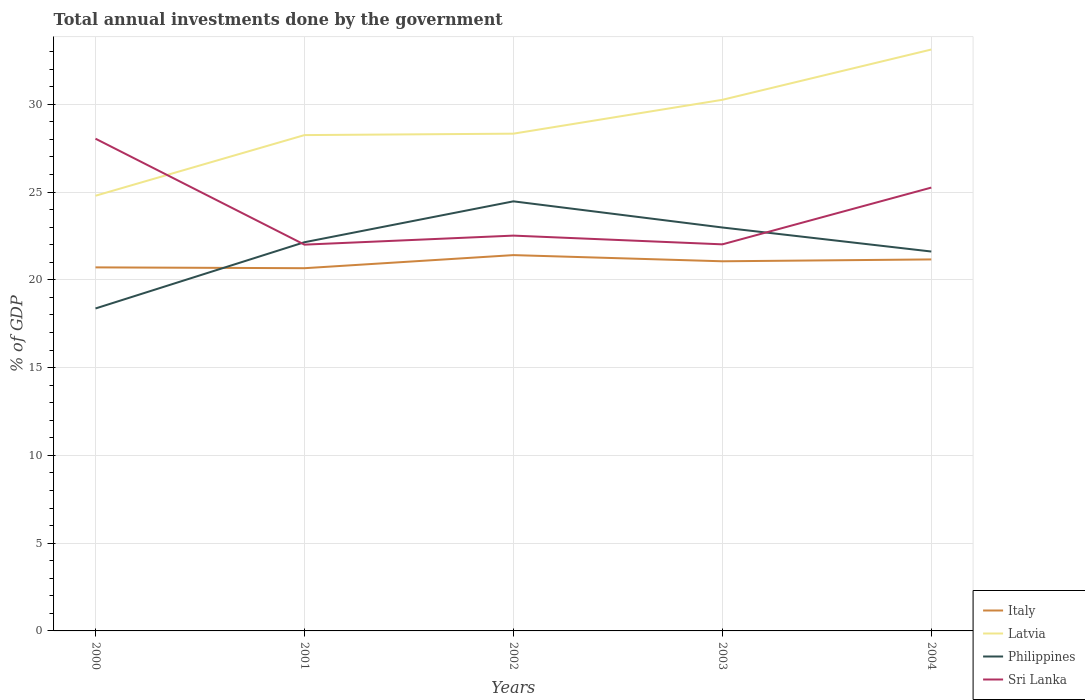How many different coloured lines are there?
Offer a terse response. 4. Across all years, what is the maximum total annual investments done by the government in Sri Lanka?
Ensure brevity in your answer.  22. What is the total total annual investments done by the government in Latvia in the graph?
Your response must be concise. -2.86. What is the difference between the highest and the second highest total annual investments done by the government in Italy?
Provide a succinct answer. 0.75. How many lines are there?
Make the answer very short. 4. How many years are there in the graph?
Make the answer very short. 5. Are the values on the major ticks of Y-axis written in scientific E-notation?
Offer a very short reply. No. Where does the legend appear in the graph?
Offer a very short reply. Bottom right. How many legend labels are there?
Your answer should be compact. 4. How are the legend labels stacked?
Keep it short and to the point. Vertical. What is the title of the graph?
Offer a very short reply. Total annual investments done by the government. What is the label or title of the X-axis?
Offer a very short reply. Years. What is the label or title of the Y-axis?
Make the answer very short. % of GDP. What is the % of GDP of Italy in 2000?
Your answer should be compact. 20.71. What is the % of GDP of Latvia in 2000?
Keep it short and to the point. 24.79. What is the % of GDP of Philippines in 2000?
Make the answer very short. 18.37. What is the % of GDP in Sri Lanka in 2000?
Your answer should be very brief. 28.04. What is the % of GDP in Italy in 2001?
Keep it short and to the point. 20.66. What is the % of GDP of Latvia in 2001?
Offer a terse response. 28.24. What is the % of GDP in Philippines in 2001?
Provide a succinct answer. 22.14. What is the % of GDP of Sri Lanka in 2001?
Provide a short and direct response. 22. What is the % of GDP in Italy in 2002?
Give a very brief answer. 21.41. What is the % of GDP of Latvia in 2002?
Provide a succinct answer. 28.33. What is the % of GDP of Philippines in 2002?
Your response must be concise. 24.47. What is the % of GDP in Sri Lanka in 2002?
Your response must be concise. 22.52. What is the % of GDP in Italy in 2003?
Your answer should be very brief. 21.06. What is the % of GDP of Latvia in 2003?
Provide a short and direct response. 30.25. What is the % of GDP in Philippines in 2003?
Give a very brief answer. 22.98. What is the % of GDP in Sri Lanka in 2003?
Ensure brevity in your answer.  22.02. What is the % of GDP of Italy in 2004?
Your answer should be very brief. 21.16. What is the % of GDP of Latvia in 2004?
Make the answer very short. 33.12. What is the % of GDP in Philippines in 2004?
Your answer should be compact. 21.61. What is the % of GDP of Sri Lanka in 2004?
Provide a short and direct response. 25.25. Across all years, what is the maximum % of GDP of Italy?
Give a very brief answer. 21.41. Across all years, what is the maximum % of GDP in Latvia?
Your response must be concise. 33.12. Across all years, what is the maximum % of GDP of Philippines?
Keep it short and to the point. 24.47. Across all years, what is the maximum % of GDP in Sri Lanka?
Offer a terse response. 28.04. Across all years, what is the minimum % of GDP of Italy?
Keep it short and to the point. 20.66. Across all years, what is the minimum % of GDP of Latvia?
Provide a short and direct response. 24.79. Across all years, what is the minimum % of GDP in Philippines?
Offer a terse response. 18.37. Across all years, what is the minimum % of GDP in Sri Lanka?
Ensure brevity in your answer.  22. What is the total % of GDP of Italy in the graph?
Offer a terse response. 105. What is the total % of GDP of Latvia in the graph?
Offer a terse response. 144.73. What is the total % of GDP in Philippines in the graph?
Provide a succinct answer. 109.57. What is the total % of GDP of Sri Lanka in the graph?
Give a very brief answer. 119.84. What is the difference between the % of GDP in Italy in 2000 and that in 2001?
Keep it short and to the point. 0.05. What is the difference between the % of GDP of Latvia in 2000 and that in 2001?
Give a very brief answer. -3.45. What is the difference between the % of GDP in Philippines in 2000 and that in 2001?
Make the answer very short. -3.77. What is the difference between the % of GDP of Sri Lanka in 2000 and that in 2001?
Your answer should be very brief. 6.04. What is the difference between the % of GDP of Italy in 2000 and that in 2002?
Your answer should be compact. -0.7. What is the difference between the % of GDP of Latvia in 2000 and that in 2002?
Ensure brevity in your answer.  -3.54. What is the difference between the % of GDP in Philippines in 2000 and that in 2002?
Provide a succinct answer. -6.1. What is the difference between the % of GDP of Sri Lanka in 2000 and that in 2002?
Your answer should be compact. 5.52. What is the difference between the % of GDP in Italy in 2000 and that in 2003?
Ensure brevity in your answer.  -0.35. What is the difference between the % of GDP of Latvia in 2000 and that in 2003?
Offer a very short reply. -5.46. What is the difference between the % of GDP of Philippines in 2000 and that in 2003?
Ensure brevity in your answer.  -4.61. What is the difference between the % of GDP of Sri Lanka in 2000 and that in 2003?
Offer a terse response. 6.02. What is the difference between the % of GDP in Italy in 2000 and that in 2004?
Your answer should be very brief. -0.45. What is the difference between the % of GDP of Latvia in 2000 and that in 2004?
Your response must be concise. -8.33. What is the difference between the % of GDP in Philippines in 2000 and that in 2004?
Provide a succinct answer. -3.24. What is the difference between the % of GDP of Sri Lanka in 2000 and that in 2004?
Your answer should be very brief. 2.79. What is the difference between the % of GDP of Italy in 2001 and that in 2002?
Ensure brevity in your answer.  -0.75. What is the difference between the % of GDP in Latvia in 2001 and that in 2002?
Your answer should be compact. -0.08. What is the difference between the % of GDP in Philippines in 2001 and that in 2002?
Give a very brief answer. -2.33. What is the difference between the % of GDP of Sri Lanka in 2001 and that in 2002?
Ensure brevity in your answer.  -0.51. What is the difference between the % of GDP of Italy in 2001 and that in 2003?
Your answer should be very brief. -0.39. What is the difference between the % of GDP in Latvia in 2001 and that in 2003?
Your answer should be compact. -2.01. What is the difference between the % of GDP in Philippines in 2001 and that in 2003?
Provide a short and direct response. -0.84. What is the difference between the % of GDP in Sri Lanka in 2001 and that in 2003?
Your answer should be very brief. -0.02. What is the difference between the % of GDP in Italy in 2001 and that in 2004?
Provide a short and direct response. -0.5. What is the difference between the % of GDP of Latvia in 2001 and that in 2004?
Ensure brevity in your answer.  -4.87. What is the difference between the % of GDP in Philippines in 2001 and that in 2004?
Give a very brief answer. 0.53. What is the difference between the % of GDP of Sri Lanka in 2001 and that in 2004?
Give a very brief answer. -3.25. What is the difference between the % of GDP of Italy in 2002 and that in 2003?
Offer a terse response. 0.35. What is the difference between the % of GDP of Latvia in 2002 and that in 2003?
Provide a short and direct response. -1.93. What is the difference between the % of GDP of Philippines in 2002 and that in 2003?
Provide a short and direct response. 1.49. What is the difference between the % of GDP of Sri Lanka in 2002 and that in 2003?
Ensure brevity in your answer.  0.5. What is the difference between the % of GDP of Italy in 2002 and that in 2004?
Your answer should be compact. 0.25. What is the difference between the % of GDP in Latvia in 2002 and that in 2004?
Ensure brevity in your answer.  -4.79. What is the difference between the % of GDP in Philippines in 2002 and that in 2004?
Keep it short and to the point. 2.86. What is the difference between the % of GDP of Sri Lanka in 2002 and that in 2004?
Your answer should be compact. -2.74. What is the difference between the % of GDP of Italy in 2003 and that in 2004?
Offer a very short reply. -0.11. What is the difference between the % of GDP in Latvia in 2003 and that in 2004?
Offer a very short reply. -2.86. What is the difference between the % of GDP in Philippines in 2003 and that in 2004?
Offer a very short reply. 1.37. What is the difference between the % of GDP in Sri Lanka in 2003 and that in 2004?
Give a very brief answer. -3.23. What is the difference between the % of GDP in Italy in 2000 and the % of GDP in Latvia in 2001?
Provide a short and direct response. -7.53. What is the difference between the % of GDP of Italy in 2000 and the % of GDP of Philippines in 2001?
Keep it short and to the point. -1.43. What is the difference between the % of GDP of Italy in 2000 and the % of GDP of Sri Lanka in 2001?
Your response must be concise. -1.29. What is the difference between the % of GDP of Latvia in 2000 and the % of GDP of Philippines in 2001?
Ensure brevity in your answer.  2.65. What is the difference between the % of GDP in Latvia in 2000 and the % of GDP in Sri Lanka in 2001?
Provide a short and direct response. 2.79. What is the difference between the % of GDP of Philippines in 2000 and the % of GDP of Sri Lanka in 2001?
Your answer should be very brief. -3.64. What is the difference between the % of GDP of Italy in 2000 and the % of GDP of Latvia in 2002?
Ensure brevity in your answer.  -7.62. What is the difference between the % of GDP in Italy in 2000 and the % of GDP in Philippines in 2002?
Your answer should be compact. -3.76. What is the difference between the % of GDP of Italy in 2000 and the % of GDP of Sri Lanka in 2002?
Your answer should be very brief. -1.81. What is the difference between the % of GDP of Latvia in 2000 and the % of GDP of Philippines in 2002?
Offer a terse response. 0.32. What is the difference between the % of GDP in Latvia in 2000 and the % of GDP in Sri Lanka in 2002?
Ensure brevity in your answer.  2.27. What is the difference between the % of GDP of Philippines in 2000 and the % of GDP of Sri Lanka in 2002?
Make the answer very short. -4.15. What is the difference between the % of GDP in Italy in 2000 and the % of GDP in Latvia in 2003?
Provide a succinct answer. -9.54. What is the difference between the % of GDP in Italy in 2000 and the % of GDP in Philippines in 2003?
Provide a short and direct response. -2.27. What is the difference between the % of GDP in Italy in 2000 and the % of GDP in Sri Lanka in 2003?
Offer a terse response. -1.31. What is the difference between the % of GDP of Latvia in 2000 and the % of GDP of Philippines in 2003?
Your answer should be very brief. 1.81. What is the difference between the % of GDP in Latvia in 2000 and the % of GDP in Sri Lanka in 2003?
Offer a very short reply. 2.77. What is the difference between the % of GDP of Philippines in 2000 and the % of GDP of Sri Lanka in 2003?
Provide a short and direct response. -3.65. What is the difference between the % of GDP in Italy in 2000 and the % of GDP in Latvia in 2004?
Your answer should be very brief. -12.41. What is the difference between the % of GDP of Italy in 2000 and the % of GDP of Philippines in 2004?
Provide a succinct answer. -0.9. What is the difference between the % of GDP of Italy in 2000 and the % of GDP of Sri Lanka in 2004?
Provide a succinct answer. -4.54. What is the difference between the % of GDP in Latvia in 2000 and the % of GDP in Philippines in 2004?
Ensure brevity in your answer.  3.18. What is the difference between the % of GDP of Latvia in 2000 and the % of GDP of Sri Lanka in 2004?
Make the answer very short. -0.46. What is the difference between the % of GDP in Philippines in 2000 and the % of GDP in Sri Lanka in 2004?
Keep it short and to the point. -6.89. What is the difference between the % of GDP in Italy in 2001 and the % of GDP in Latvia in 2002?
Provide a short and direct response. -7.66. What is the difference between the % of GDP in Italy in 2001 and the % of GDP in Philippines in 2002?
Give a very brief answer. -3.81. What is the difference between the % of GDP of Italy in 2001 and the % of GDP of Sri Lanka in 2002?
Provide a succinct answer. -1.86. What is the difference between the % of GDP in Latvia in 2001 and the % of GDP in Philippines in 2002?
Offer a very short reply. 3.77. What is the difference between the % of GDP of Latvia in 2001 and the % of GDP of Sri Lanka in 2002?
Ensure brevity in your answer.  5.73. What is the difference between the % of GDP in Philippines in 2001 and the % of GDP in Sri Lanka in 2002?
Make the answer very short. -0.38. What is the difference between the % of GDP of Italy in 2001 and the % of GDP of Latvia in 2003?
Offer a very short reply. -9.59. What is the difference between the % of GDP in Italy in 2001 and the % of GDP in Philippines in 2003?
Provide a short and direct response. -2.32. What is the difference between the % of GDP in Italy in 2001 and the % of GDP in Sri Lanka in 2003?
Give a very brief answer. -1.36. What is the difference between the % of GDP of Latvia in 2001 and the % of GDP of Philippines in 2003?
Your answer should be compact. 5.26. What is the difference between the % of GDP of Latvia in 2001 and the % of GDP of Sri Lanka in 2003?
Give a very brief answer. 6.22. What is the difference between the % of GDP in Philippines in 2001 and the % of GDP in Sri Lanka in 2003?
Your answer should be very brief. 0.12. What is the difference between the % of GDP in Italy in 2001 and the % of GDP in Latvia in 2004?
Keep it short and to the point. -12.46. What is the difference between the % of GDP in Italy in 2001 and the % of GDP in Philippines in 2004?
Keep it short and to the point. -0.95. What is the difference between the % of GDP of Italy in 2001 and the % of GDP of Sri Lanka in 2004?
Offer a terse response. -4.59. What is the difference between the % of GDP of Latvia in 2001 and the % of GDP of Philippines in 2004?
Make the answer very short. 6.63. What is the difference between the % of GDP in Latvia in 2001 and the % of GDP in Sri Lanka in 2004?
Give a very brief answer. 2.99. What is the difference between the % of GDP in Philippines in 2001 and the % of GDP in Sri Lanka in 2004?
Provide a succinct answer. -3.11. What is the difference between the % of GDP of Italy in 2002 and the % of GDP of Latvia in 2003?
Your answer should be compact. -8.85. What is the difference between the % of GDP of Italy in 2002 and the % of GDP of Philippines in 2003?
Ensure brevity in your answer.  -1.57. What is the difference between the % of GDP in Italy in 2002 and the % of GDP in Sri Lanka in 2003?
Offer a terse response. -0.61. What is the difference between the % of GDP of Latvia in 2002 and the % of GDP of Philippines in 2003?
Your response must be concise. 5.34. What is the difference between the % of GDP in Latvia in 2002 and the % of GDP in Sri Lanka in 2003?
Offer a terse response. 6.3. What is the difference between the % of GDP in Philippines in 2002 and the % of GDP in Sri Lanka in 2003?
Ensure brevity in your answer.  2.45. What is the difference between the % of GDP of Italy in 2002 and the % of GDP of Latvia in 2004?
Offer a very short reply. -11.71. What is the difference between the % of GDP in Italy in 2002 and the % of GDP in Philippines in 2004?
Ensure brevity in your answer.  -0.2. What is the difference between the % of GDP of Italy in 2002 and the % of GDP of Sri Lanka in 2004?
Keep it short and to the point. -3.85. What is the difference between the % of GDP in Latvia in 2002 and the % of GDP in Philippines in 2004?
Offer a terse response. 6.71. What is the difference between the % of GDP of Latvia in 2002 and the % of GDP of Sri Lanka in 2004?
Your answer should be compact. 3.07. What is the difference between the % of GDP of Philippines in 2002 and the % of GDP of Sri Lanka in 2004?
Offer a terse response. -0.78. What is the difference between the % of GDP in Italy in 2003 and the % of GDP in Latvia in 2004?
Provide a succinct answer. -12.06. What is the difference between the % of GDP of Italy in 2003 and the % of GDP of Philippines in 2004?
Offer a very short reply. -0.56. What is the difference between the % of GDP of Italy in 2003 and the % of GDP of Sri Lanka in 2004?
Make the answer very short. -4.2. What is the difference between the % of GDP in Latvia in 2003 and the % of GDP in Philippines in 2004?
Make the answer very short. 8.64. What is the difference between the % of GDP in Latvia in 2003 and the % of GDP in Sri Lanka in 2004?
Offer a very short reply. 5. What is the difference between the % of GDP of Philippines in 2003 and the % of GDP of Sri Lanka in 2004?
Keep it short and to the point. -2.27. What is the average % of GDP in Italy per year?
Make the answer very short. 21. What is the average % of GDP in Latvia per year?
Your answer should be very brief. 28.95. What is the average % of GDP in Philippines per year?
Make the answer very short. 21.91. What is the average % of GDP of Sri Lanka per year?
Ensure brevity in your answer.  23.97. In the year 2000, what is the difference between the % of GDP of Italy and % of GDP of Latvia?
Provide a succinct answer. -4.08. In the year 2000, what is the difference between the % of GDP in Italy and % of GDP in Philippines?
Your answer should be very brief. 2.34. In the year 2000, what is the difference between the % of GDP in Italy and % of GDP in Sri Lanka?
Offer a very short reply. -7.33. In the year 2000, what is the difference between the % of GDP in Latvia and % of GDP in Philippines?
Offer a very short reply. 6.42. In the year 2000, what is the difference between the % of GDP of Latvia and % of GDP of Sri Lanka?
Ensure brevity in your answer.  -3.25. In the year 2000, what is the difference between the % of GDP in Philippines and % of GDP in Sri Lanka?
Your answer should be compact. -9.67. In the year 2001, what is the difference between the % of GDP in Italy and % of GDP in Latvia?
Your answer should be compact. -7.58. In the year 2001, what is the difference between the % of GDP of Italy and % of GDP of Philippines?
Your response must be concise. -1.48. In the year 2001, what is the difference between the % of GDP in Italy and % of GDP in Sri Lanka?
Offer a very short reply. -1.34. In the year 2001, what is the difference between the % of GDP in Latvia and % of GDP in Philippines?
Provide a succinct answer. 6.1. In the year 2001, what is the difference between the % of GDP of Latvia and % of GDP of Sri Lanka?
Ensure brevity in your answer.  6.24. In the year 2001, what is the difference between the % of GDP of Philippines and % of GDP of Sri Lanka?
Make the answer very short. 0.14. In the year 2002, what is the difference between the % of GDP of Italy and % of GDP of Latvia?
Provide a short and direct response. -6.92. In the year 2002, what is the difference between the % of GDP in Italy and % of GDP in Philippines?
Give a very brief answer. -3.06. In the year 2002, what is the difference between the % of GDP in Italy and % of GDP in Sri Lanka?
Offer a terse response. -1.11. In the year 2002, what is the difference between the % of GDP of Latvia and % of GDP of Philippines?
Your response must be concise. 3.85. In the year 2002, what is the difference between the % of GDP of Latvia and % of GDP of Sri Lanka?
Offer a very short reply. 5.81. In the year 2002, what is the difference between the % of GDP in Philippines and % of GDP in Sri Lanka?
Give a very brief answer. 1.95. In the year 2003, what is the difference between the % of GDP of Italy and % of GDP of Latvia?
Your answer should be very brief. -9.2. In the year 2003, what is the difference between the % of GDP in Italy and % of GDP in Philippines?
Your answer should be very brief. -1.92. In the year 2003, what is the difference between the % of GDP in Italy and % of GDP in Sri Lanka?
Offer a very short reply. -0.96. In the year 2003, what is the difference between the % of GDP of Latvia and % of GDP of Philippines?
Provide a succinct answer. 7.27. In the year 2003, what is the difference between the % of GDP in Latvia and % of GDP in Sri Lanka?
Your answer should be compact. 8.23. In the year 2003, what is the difference between the % of GDP in Philippines and % of GDP in Sri Lanka?
Offer a terse response. 0.96. In the year 2004, what is the difference between the % of GDP in Italy and % of GDP in Latvia?
Your answer should be very brief. -11.96. In the year 2004, what is the difference between the % of GDP of Italy and % of GDP of Philippines?
Your answer should be compact. -0.45. In the year 2004, what is the difference between the % of GDP of Italy and % of GDP of Sri Lanka?
Provide a succinct answer. -4.09. In the year 2004, what is the difference between the % of GDP of Latvia and % of GDP of Philippines?
Give a very brief answer. 11.51. In the year 2004, what is the difference between the % of GDP in Latvia and % of GDP in Sri Lanka?
Offer a terse response. 7.86. In the year 2004, what is the difference between the % of GDP in Philippines and % of GDP in Sri Lanka?
Provide a short and direct response. -3.64. What is the ratio of the % of GDP in Latvia in 2000 to that in 2001?
Your response must be concise. 0.88. What is the ratio of the % of GDP of Philippines in 2000 to that in 2001?
Your answer should be very brief. 0.83. What is the ratio of the % of GDP in Sri Lanka in 2000 to that in 2001?
Your response must be concise. 1.27. What is the ratio of the % of GDP of Italy in 2000 to that in 2002?
Give a very brief answer. 0.97. What is the ratio of the % of GDP of Latvia in 2000 to that in 2002?
Keep it short and to the point. 0.88. What is the ratio of the % of GDP in Philippines in 2000 to that in 2002?
Keep it short and to the point. 0.75. What is the ratio of the % of GDP in Sri Lanka in 2000 to that in 2002?
Give a very brief answer. 1.25. What is the ratio of the % of GDP of Italy in 2000 to that in 2003?
Provide a succinct answer. 0.98. What is the ratio of the % of GDP of Latvia in 2000 to that in 2003?
Offer a terse response. 0.82. What is the ratio of the % of GDP of Philippines in 2000 to that in 2003?
Give a very brief answer. 0.8. What is the ratio of the % of GDP in Sri Lanka in 2000 to that in 2003?
Give a very brief answer. 1.27. What is the ratio of the % of GDP of Italy in 2000 to that in 2004?
Your response must be concise. 0.98. What is the ratio of the % of GDP of Latvia in 2000 to that in 2004?
Your answer should be compact. 0.75. What is the ratio of the % of GDP in Philippines in 2000 to that in 2004?
Give a very brief answer. 0.85. What is the ratio of the % of GDP in Sri Lanka in 2000 to that in 2004?
Your answer should be compact. 1.11. What is the ratio of the % of GDP of Italy in 2001 to that in 2002?
Keep it short and to the point. 0.97. What is the ratio of the % of GDP in Latvia in 2001 to that in 2002?
Keep it short and to the point. 1. What is the ratio of the % of GDP of Philippines in 2001 to that in 2002?
Your answer should be very brief. 0.9. What is the ratio of the % of GDP in Sri Lanka in 2001 to that in 2002?
Offer a terse response. 0.98. What is the ratio of the % of GDP of Italy in 2001 to that in 2003?
Provide a succinct answer. 0.98. What is the ratio of the % of GDP in Latvia in 2001 to that in 2003?
Your answer should be very brief. 0.93. What is the ratio of the % of GDP of Philippines in 2001 to that in 2003?
Make the answer very short. 0.96. What is the ratio of the % of GDP of Sri Lanka in 2001 to that in 2003?
Offer a terse response. 1. What is the ratio of the % of GDP of Italy in 2001 to that in 2004?
Your answer should be very brief. 0.98. What is the ratio of the % of GDP in Latvia in 2001 to that in 2004?
Give a very brief answer. 0.85. What is the ratio of the % of GDP of Philippines in 2001 to that in 2004?
Give a very brief answer. 1.02. What is the ratio of the % of GDP in Sri Lanka in 2001 to that in 2004?
Keep it short and to the point. 0.87. What is the ratio of the % of GDP in Italy in 2002 to that in 2003?
Provide a succinct answer. 1.02. What is the ratio of the % of GDP in Latvia in 2002 to that in 2003?
Keep it short and to the point. 0.94. What is the ratio of the % of GDP of Philippines in 2002 to that in 2003?
Provide a short and direct response. 1.06. What is the ratio of the % of GDP in Sri Lanka in 2002 to that in 2003?
Offer a very short reply. 1.02. What is the ratio of the % of GDP in Italy in 2002 to that in 2004?
Offer a terse response. 1.01. What is the ratio of the % of GDP in Latvia in 2002 to that in 2004?
Your response must be concise. 0.86. What is the ratio of the % of GDP in Philippines in 2002 to that in 2004?
Ensure brevity in your answer.  1.13. What is the ratio of the % of GDP of Sri Lanka in 2002 to that in 2004?
Offer a very short reply. 0.89. What is the ratio of the % of GDP in Italy in 2003 to that in 2004?
Your response must be concise. 0.99. What is the ratio of the % of GDP of Latvia in 2003 to that in 2004?
Provide a short and direct response. 0.91. What is the ratio of the % of GDP in Philippines in 2003 to that in 2004?
Make the answer very short. 1.06. What is the ratio of the % of GDP of Sri Lanka in 2003 to that in 2004?
Offer a terse response. 0.87. What is the difference between the highest and the second highest % of GDP of Italy?
Give a very brief answer. 0.25. What is the difference between the highest and the second highest % of GDP of Latvia?
Provide a short and direct response. 2.86. What is the difference between the highest and the second highest % of GDP in Philippines?
Provide a short and direct response. 1.49. What is the difference between the highest and the second highest % of GDP in Sri Lanka?
Make the answer very short. 2.79. What is the difference between the highest and the lowest % of GDP in Italy?
Keep it short and to the point. 0.75. What is the difference between the highest and the lowest % of GDP of Latvia?
Offer a very short reply. 8.33. What is the difference between the highest and the lowest % of GDP in Philippines?
Your answer should be very brief. 6.1. What is the difference between the highest and the lowest % of GDP of Sri Lanka?
Your response must be concise. 6.04. 